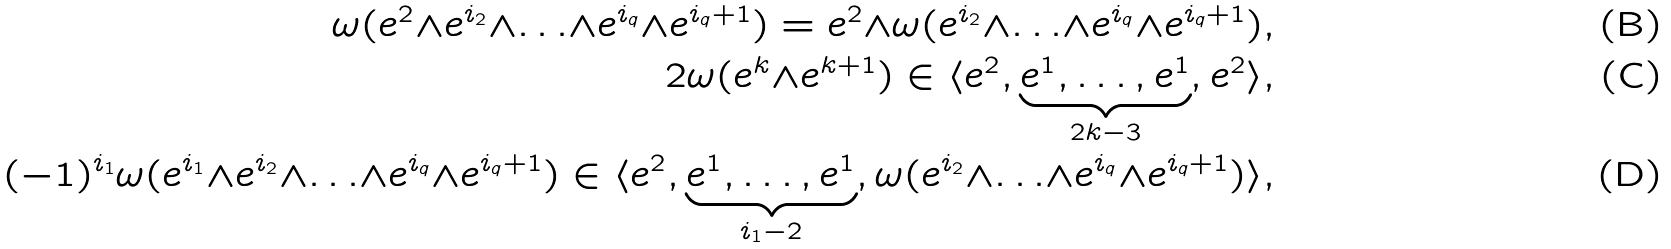<formula> <loc_0><loc_0><loc_500><loc_500>\omega ( e ^ { 2 } { \wedge } e ^ { i _ { 2 } } { \wedge } { \dots } { \wedge } e ^ { i _ { q } } { \wedge } e ^ { i _ { q } { + } 1 } ) = e ^ { 2 } { \wedge } \omega ( e ^ { i _ { 2 } } { \wedge } { \dots } { \wedge } e ^ { i _ { q } } { \wedge } e ^ { i _ { q } { + } 1 } ) , \\ 2 \omega ( e ^ { k } { \wedge } e ^ { k { + } 1 } ) \in \langle e ^ { 2 } , \underbrace { e ^ { 1 } , \dots , e ^ { 1 } } _ { 2 k - 3 } , e ^ { 2 } \rangle , \\ ( - 1 ) ^ { i _ { 1 } } \omega ( e ^ { i _ { 1 } } { \wedge } e ^ { i _ { 2 } } { \wedge } { \dots } { \wedge } e ^ { i _ { q } } { \wedge } e ^ { i _ { q } { + } 1 } ) \in \langle e ^ { 2 } , \underbrace { e ^ { 1 } , \dots , e ^ { 1 } } _ { i _ { 1 } - 2 } , \omega ( e ^ { i _ { 2 } } { \wedge } { \dots } { \wedge } e ^ { i _ { q } } { \wedge } e ^ { i _ { q } { + } 1 } ) \rangle ,</formula> 